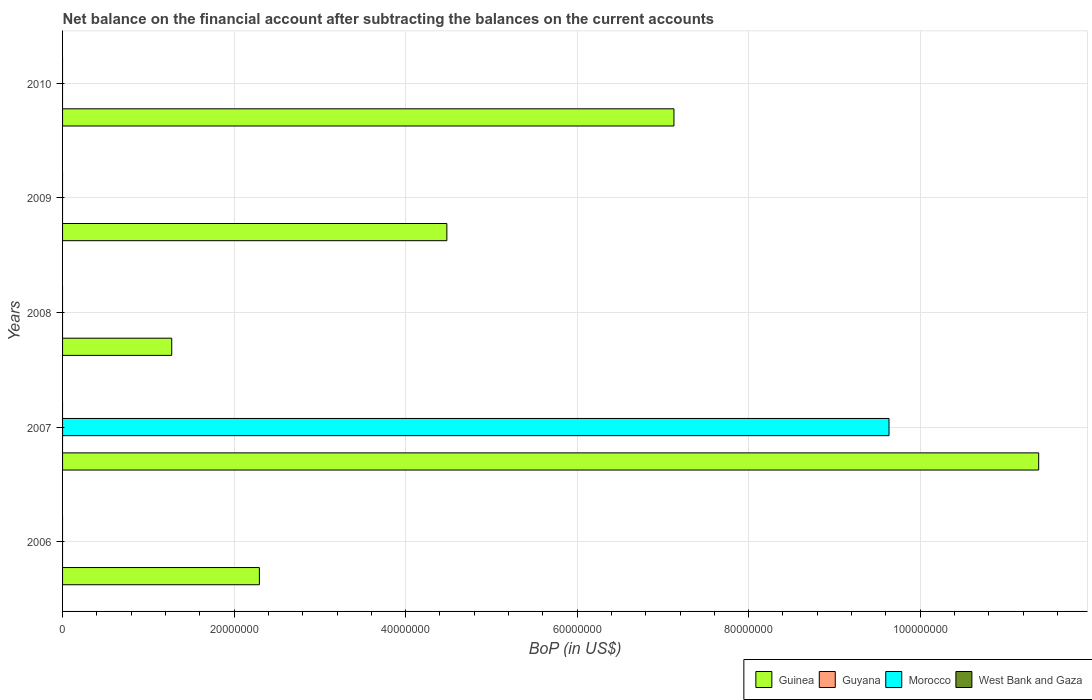What is the label of the 3rd group of bars from the top?
Ensure brevity in your answer.  2008. In how many cases, is the number of bars for a given year not equal to the number of legend labels?
Your response must be concise. 5. What is the Balance of Payments in Guinea in 2007?
Offer a very short reply. 1.14e+08. Across all years, what is the maximum Balance of Payments in Morocco?
Give a very brief answer. 9.64e+07. Across all years, what is the minimum Balance of Payments in Guinea?
Offer a very short reply. 1.27e+07. In which year was the Balance of Payments in Guinea maximum?
Provide a succinct answer. 2007. What is the total Balance of Payments in Morocco in the graph?
Your answer should be very brief. 9.64e+07. What is the difference between the Balance of Payments in Guinea in 2007 and that in 2009?
Provide a short and direct response. 6.90e+07. What is the difference between the Balance of Payments in West Bank and Gaza in 2009 and the Balance of Payments in Morocco in 2007?
Make the answer very short. -9.64e+07. What is the average Balance of Payments in Morocco per year?
Provide a succinct answer. 1.93e+07. In the year 2007, what is the difference between the Balance of Payments in Guinea and Balance of Payments in Morocco?
Keep it short and to the point. 1.75e+07. What is the difference between the highest and the lowest Balance of Payments in Morocco?
Give a very brief answer. 9.64e+07. Is it the case that in every year, the sum of the Balance of Payments in Guinea and Balance of Payments in West Bank and Gaza is greater than the sum of Balance of Payments in Morocco and Balance of Payments in Guyana?
Your answer should be compact. Yes. How many years are there in the graph?
Provide a succinct answer. 5. Are the values on the major ticks of X-axis written in scientific E-notation?
Give a very brief answer. No. How many legend labels are there?
Offer a terse response. 4. How are the legend labels stacked?
Give a very brief answer. Horizontal. What is the title of the graph?
Your answer should be compact. Net balance on the financial account after subtracting the balances on the current accounts. What is the label or title of the X-axis?
Your response must be concise. BoP (in US$). What is the BoP (in US$) in Guinea in 2006?
Provide a succinct answer. 2.30e+07. What is the BoP (in US$) in Guyana in 2006?
Offer a very short reply. 0. What is the BoP (in US$) in Morocco in 2006?
Provide a succinct answer. 0. What is the BoP (in US$) in Guinea in 2007?
Offer a terse response. 1.14e+08. What is the BoP (in US$) of Morocco in 2007?
Give a very brief answer. 9.64e+07. What is the BoP (in US$) of West Bank and Gaza in 2007?
Make the answer very short. 0. What is the BoP (in US$) of Guinea in 2008?
Make the answer very short. 1.27e+07. What is the BoP (in US$) in Morocco in 2008?
Your answer should be very brief. 0. What is the BoP (in US$) of Guinea in 2009?
Offer a very short reply. 4.48e+07. What is the BoP (in US$) of Morocco in 2009?
Offer a very short reply. 0. What is the BoP (in US$) in Guinea in 2010?
Offer a very short reply. 7.13e+07. What is the BoP (in US$) of Guyana in 2010?
Make the answer very short. 0. What is the BoP (in US$) in Morocco in 2010?
Your answer should be compact. 0. Across all years, what is the maximum BoP (in US$) in Guinea?
Keep it short and to the point. 1.14e+08. Across all years, what is the maximum BoP (in US$) in Morocco?
Offer a terse response. 9.64e+07. Across all years, what is the minimum BoP (in US$) of Guinea?
Give a very brief answer. 1.27e+07. Across all years, what is the minimum BoP (in US$) in Morocco?
Your response must be concise. 0. What is the total BoP (in US$) in Guinea in the graph?
Keep it short and to the point. 2.66e+08. What is the total BoP (in US$) in Guyana in the graph?
Give a very brief answer. 0. What is the total BoP (in US$) in Morocco in the graph?
Your response must be concise. 9.64e+07. What is the difference between the BoP (in US$) in Guinea in 2006 and that in 2007?
Your response must be concise. -9.09e+07. What is the difference between the BoP (in US$) of Guinea in 2006 and that in 2008?
Offer a very short reply. 1.02e+07. What is the difference between the BoP (in US$) of Guinea in 2006 and that in 2009?
Your response must be concise. -2.19e+07. What is the difference between the BoP (in US$) in Guinea in 2006 and that in 2010?
Your answer should be very brief. -4.83e+07. What is the difference between the BoP (in US$) of Guinea in 2007 and that in 2008?
Provide a succinct answer. 1.01e+08. What is the difference between the BoP (in US$) of Guinea in 2007 and that in 2009?
Offer a terse response. 6.90e+07. What is the difference between the BoP (in US$) of Guinea in 2007 and that in 2010?
Give a very brief answer. 4.25e+07. What is the difference between the BoP (in US$) in Guinea in 2008 and that in 2009?
Offer a very short reply. -3.21e+07. What is the difference between the BoP (in US$) of Guinea in 2008 and that in 2010?
Your response must be concise. -5.86e+07. What is the difference between the BoP (in US$) in Guinea in 2009 and that in 2010?
Give a very brief answer. -2.65e+07. What is the difference between the BoP (in US$) in Guinea in 2006 and the BoP (in US$) in Morocco in 2007?
Your answer should be compact. -7.34e+07. What is the average BoP (in US$) of Guinea per year?
Make the answer very short. 5.31e+07. What is the average BoP (in US$) of Morocco per year?
Keep it short and to the point. 1.93e+07. In the year 2007, what is the difference between the BoP (in US$) in Guinea and BoP (in US$) in Morocco?
Make the answer very short. 1.75e+07. What is the ratio of the BoP (in US$) in Guinea in 2006 to that in 2007?
Provide a succinct answer. 0.2. What is the ratio of the BoP (in US$) of Guinea in 2006 to that in 2008?
Keep it short and to the point. 1.8. What is the ratio of the BoP (in US$) of Guinea in 2006 to that in 2009?
Your answer should be compact. 0.51. What is the ratio of the BoP (in US$) of Guinea in 2006 to that in 2010?
Make the answer very short. 0.32. What is the ratio of the BoP (in US$) in Guinea in 2007 to that in 2008?
Keep it short and to the point. 8.94. What is the ratio of the BoP (in US$) in Guinea in 2007 to that in 2009?
Give a very brief answer. 2.54. What is the ratio of the BoP (in US$) of Guinea in 2007 to that in 2010?
Your answer should be compact. 1.6. What is the ratio of the BoP (in US$) in Guinea in 2008 to that in 2009?
Your answer should be very brief. 0.28. What is the ratio of the BoP (in US$) of Guinea in 2008 to that in 2010?
Ensure brevity in your answer.  0.18. What is the ratio of the BoP (in US$) of Guinea in 2009 to that in 2010?
Keep it short and to the point. 0.63. What is the difference between the highest and the second highest BoP (in US$) of Guinea?
Your answer should be compact. 4.25e+07. What is the difference between the highest and the lowest BoP (in US$) in Guinea?
Your response must be concise. 1.01e+08. What is the difference between the highest and the lowest BoP (in US$) of Morocco?
Make the answer very short. 9.64e+07. 